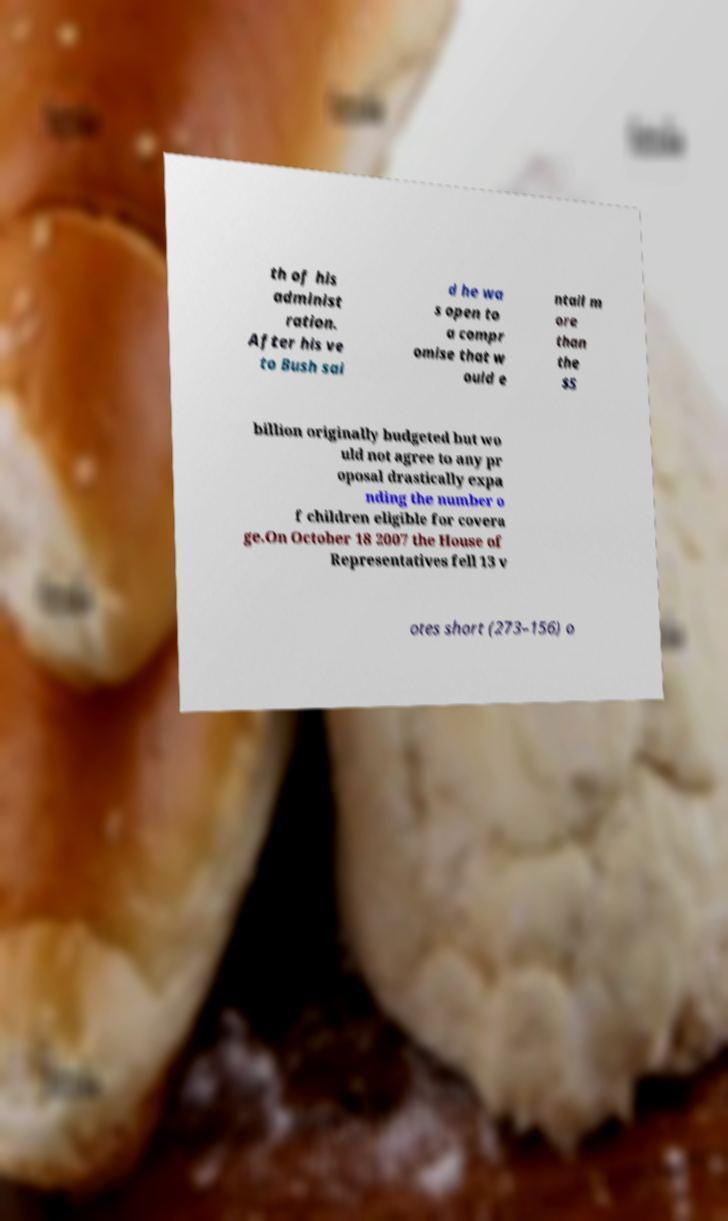Could you extract and type out the text from this image? th of his administ ration. After his ve to Bush sai d he wa s open to a compr omise that w ould e ntail m ore than the $5 billion originally budgeted but wo uld not agree to any pr oposal drastically expa nding the number o f children eligible for covera ge.On October 18 2007 the House of Representatives fell 13 v otes short (273–156) o 